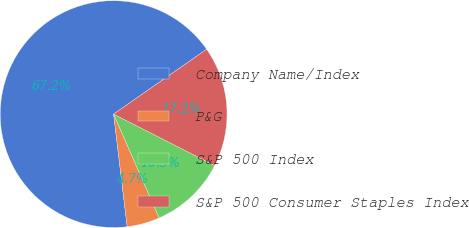<chart> <loc_0><loc_0><loc_500><loc_500><pie_chart><fcel>Company Name/Index<fcel>P&G<fcel>S&P 500 Index<fcel>S&P 500 Consumer Staples Index<nl><fcel>67.22%<fcel>4.67%<fcel>10.93%<fcel>17.18%<nl></chart> 